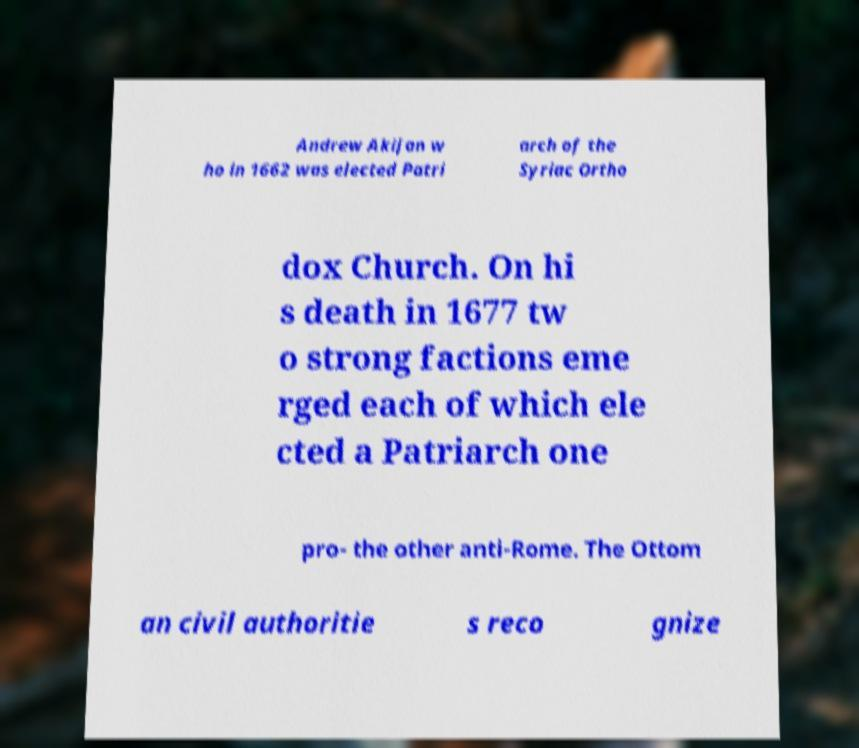Could you extract and type out the text from this image? Andrew Akijan w ho in 1662 was elected Patri arch of the Syriac Ortho dox Church. On hi s death in 1677 tw o strong factions eme rged each of which ele cted a Patriarch one pro- the other anti-Rome. The Ottom an civil authoritie s reco gnize 